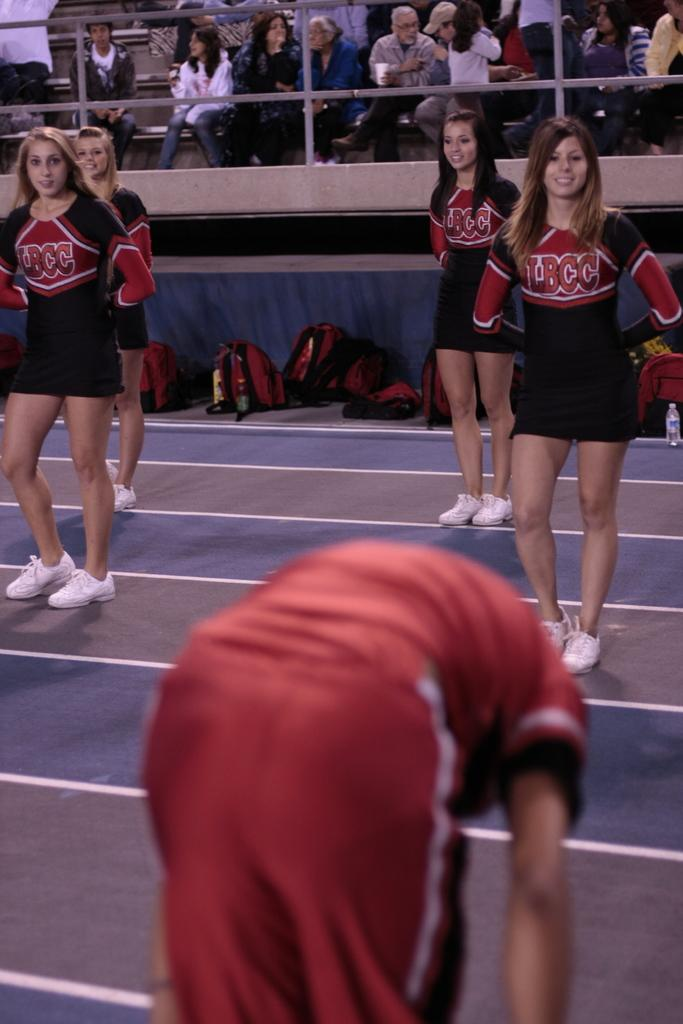<image>
Give a short and clear explanation of the subsequent image. guy in red bent over in front of 4 lbcc cheerleaders and small crowd in the stands 